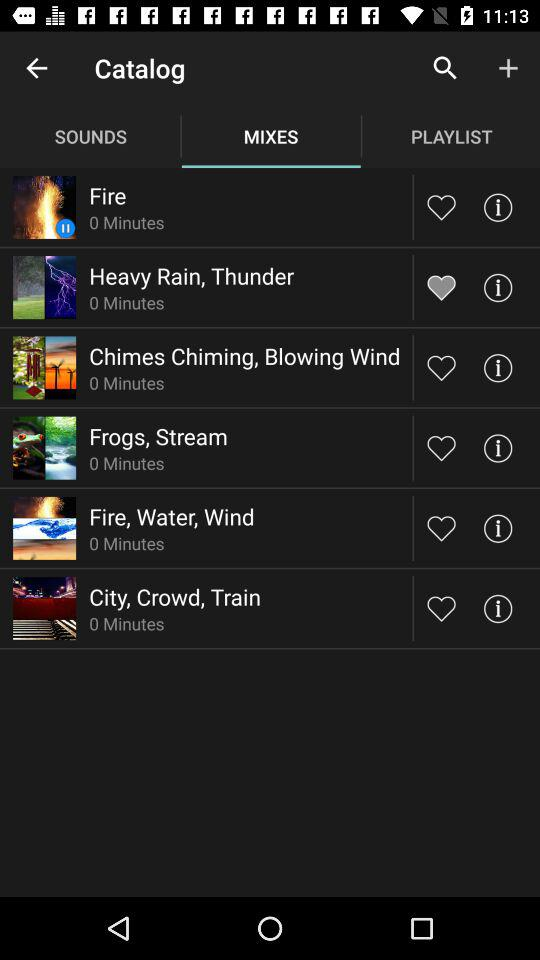What is the duration of the "Heavy Rain, Thunder" mix? The duration of the "Heavy Rain, Thunder" mix is 0 minutes. 